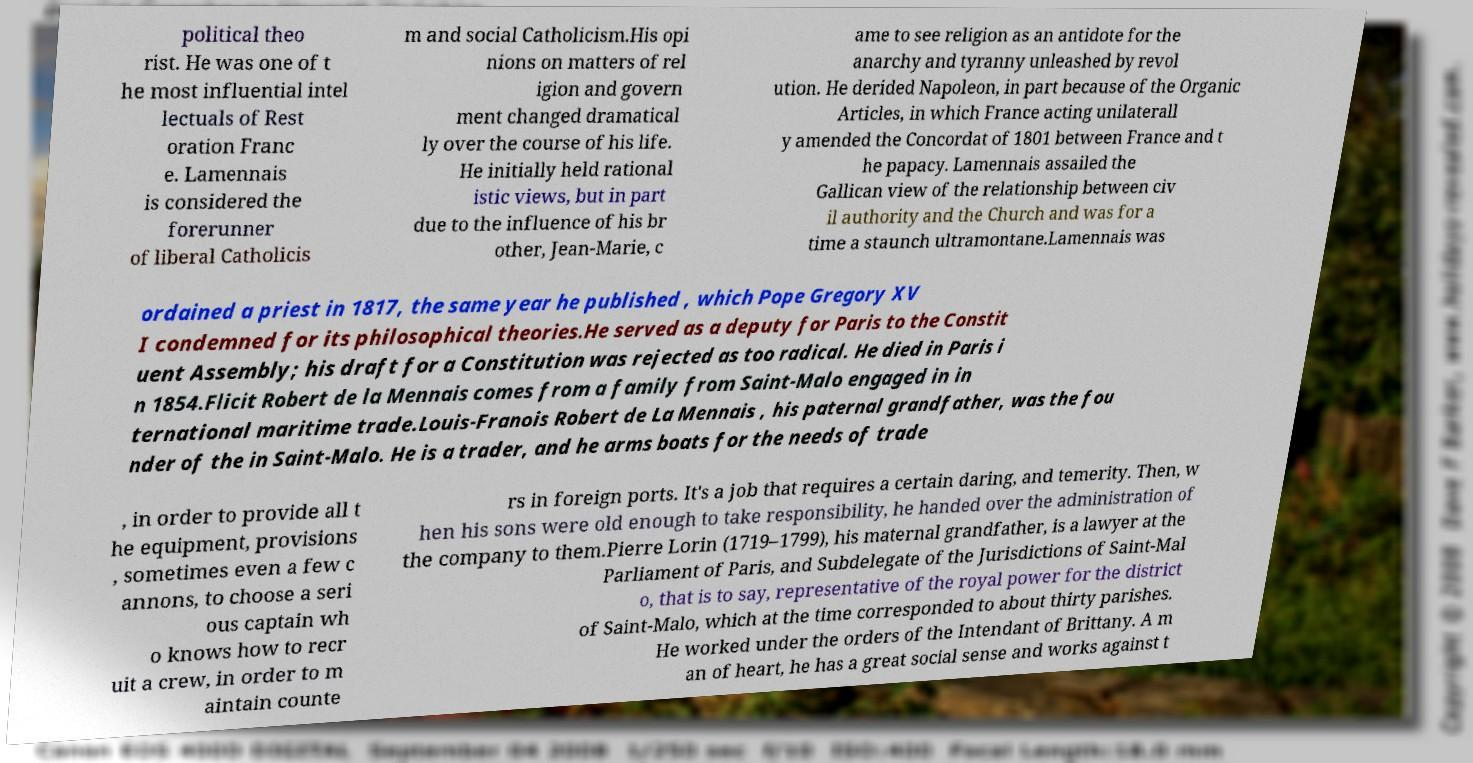I need the written content from this picture converted into text. Can you do that? political theo rist. He was one of t he most influential intel lectuals of Rest oration Franc e. Lamennais is considered the forerunner of liberal Catholicis m and social Catholicism.His opi nions on matters of rel igion and govern ment changed dramatical ly over the course of his life. He initially held rational istic views, but in part due to the influence of his br other, Jean-Marie, c ame to see religion as an antidote for the anarchy and tyranny unleashed by revol ution. He derided Napoleon, in part because of the Organic Articles, in which France acting unilaterall y amended the Concordat of 1801 between France and t he papacy. Lamennais assailed the Gallican view of the relationship between civ il authority and the Church and was for a time a staunch ultramontane.Lamennais was ordained a priest in 1817, the same year he published , which Pope Gregory XV I condemned for its philosophical theories.He served as a deputy for Paris to the Constit uent Assembly; his draft for a Constitution was rejected as too radical. He died in Paris i n 1854.Flicit Robert de la Mennais comes from a family from Saint-Malo engaged in in ternational maritime trade.Louis-Franois Robert de La Mennais , his paternal grandfather, was the fou nder of the in Saint-Malo. He is a trader, and he arms boats for the needs of trade , in order to provide all t he equipment, provisions , sometimes even a few c annons, to choose a seri ous captain wh o knows how to recr uit a crew, in order to m aintain counte rs in foreign ports. It's a job that requires a certain daring, and temerity. Then, w hen his sons were old enough to take responsibility, he handed over the administration of the company to them.Pierre Lorin (1719–1799), his maternal grandfather, is a lawyer at the Parliament of Paris, and Subdelegate of the Jurisdictions of Saint-Mal o, that is to say, representative of the royal power for the district of Saint-Malo, which at the time corresponded to about thirty parishes. He worked under the orders of the Intendant of Brittany. A m an of heart, he has a great social sense and works against t 